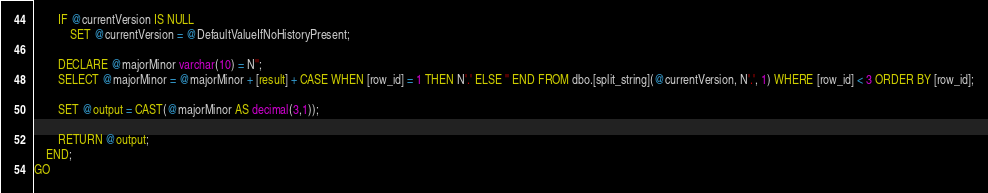Convert code to text. <code><loc_0><loc_0><loc_500><loc_500><_SQL_>		IF @currentVersion IS NULL 
			SET @currentVersion = @DefaultValueIfNoHistoryPresent;
			
		DECLARE @majorMinor varchar(10) = N'';
		SELECT @majorMinor = @majorMinor + [result] + CASE WHEN [row_id] = 1 THEN N'.' ELSE '' END FROM dbo.[split_string](@currentVersion, N'.', 1) WHERE [row_id] < 3 ORDER BY [row_id];

		SET @output = CAST(@majorMinor AS decimal(3,1));

    	RETURN @output;
    END;
GO</code> 